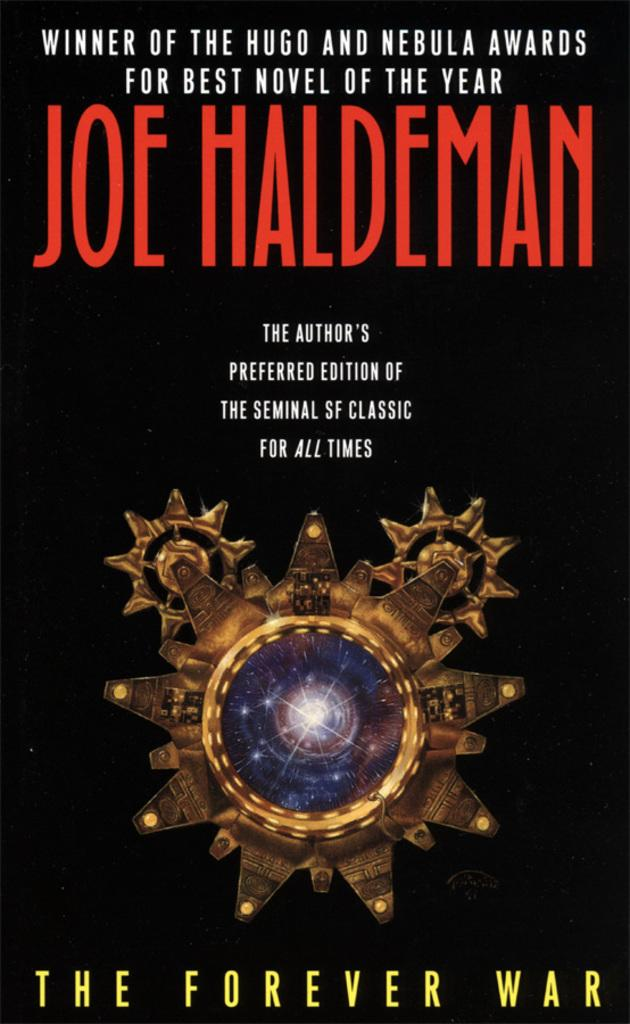Provide a one-sentence caption for the provided image. a book THE FOREVER WAR by JOE HALDEMAN. 